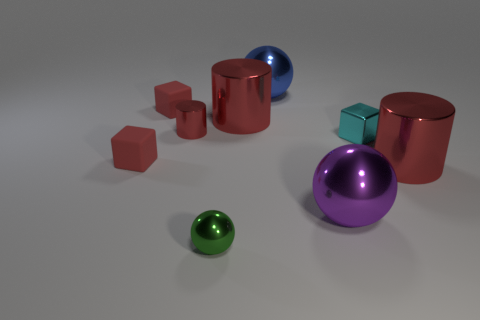Subtract all small matte blocks. How many blocks are left? 1 Subtract all blue cylinders. How many red blocks are left? 2 Subtract 1 cylinders. How many cylinders are left? 2 Subtract all yellow cylinders. Subtract all purple balls. How many cylinders are left? 3 Subtract all purple matte cylinders. Subtract all metallic spheres. How many objects are left? 6 Add 5 tiny green metal spheres. How many tiny green metal spheres are left? 6 Add 7 tiny blocks. How many tiny blocks exist? 10 Subtract 0 gray blocks. How many objects are left? 9 Subtract all cylinders. How many objects are left? 6 